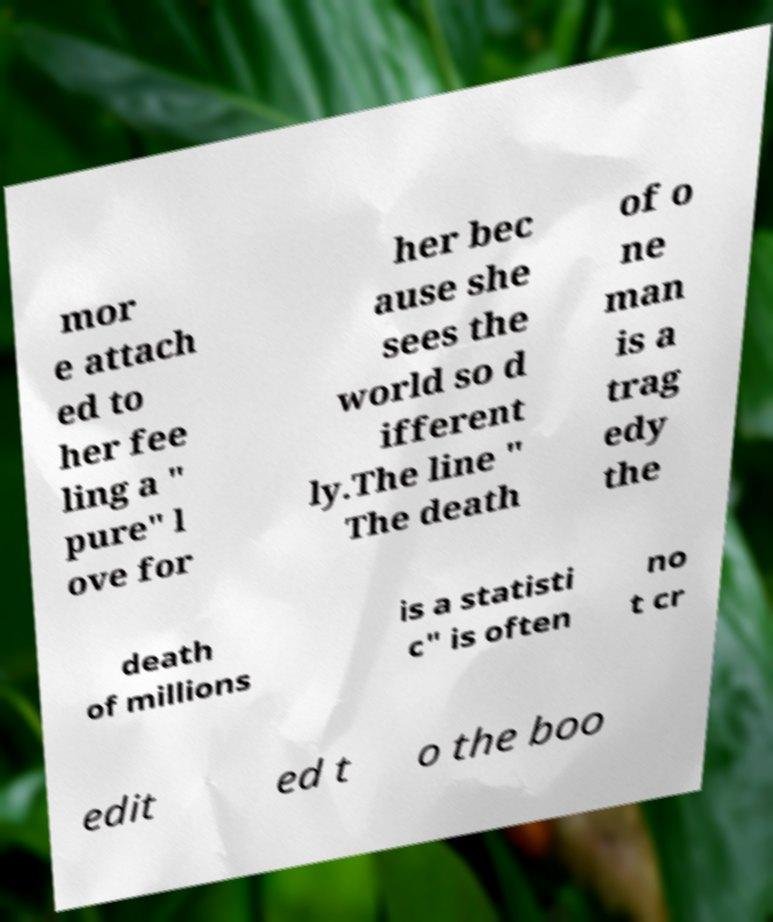Please identify and transcribe the text found in this image. mor e attach ed to her fee ling a " pure" l ove for her bec ause she sees the world so d ifferent ly.The line " The death of o ne man is a trag edy the death of millions is a statisti c" is often no t cr edit ed t o the boo 